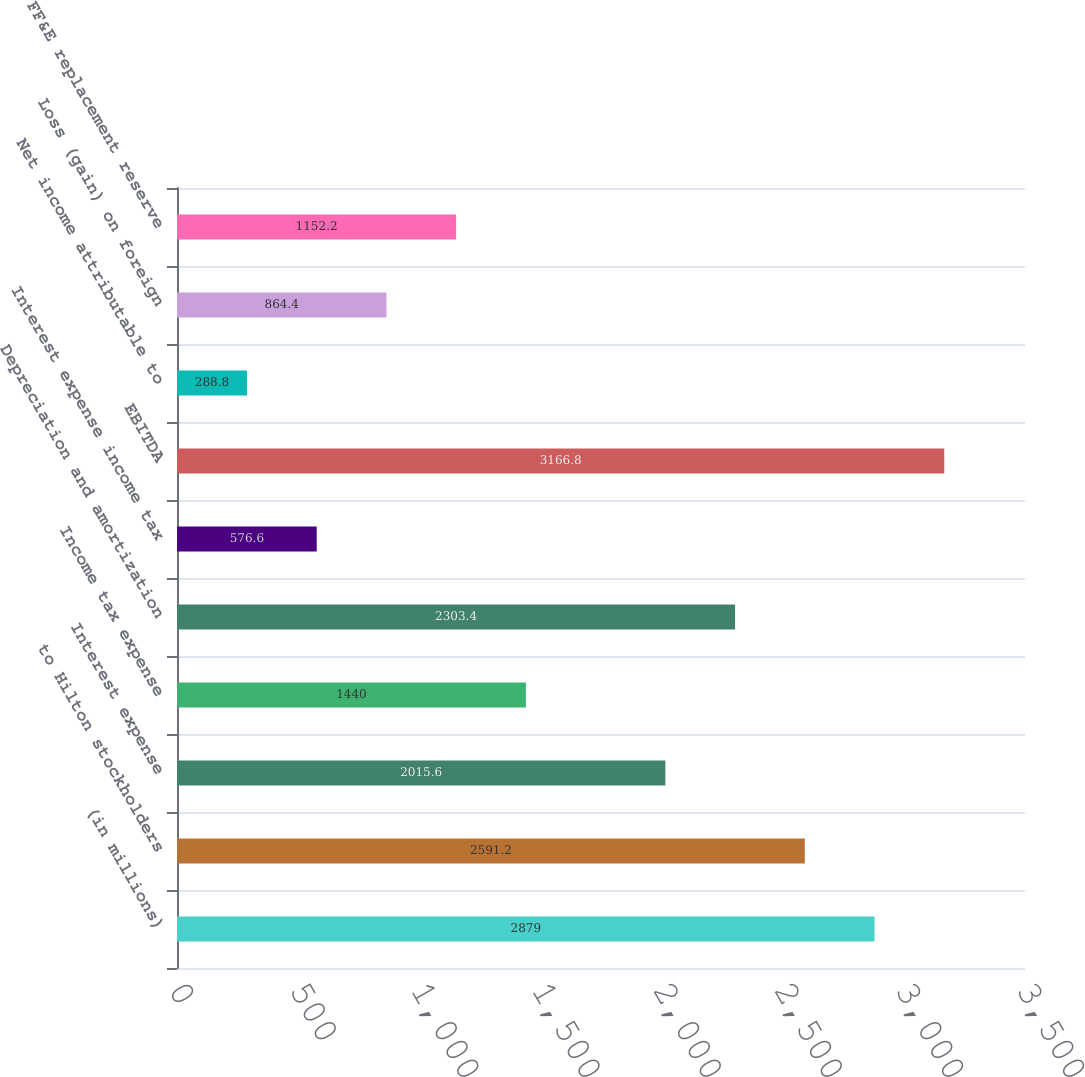Convert chart. <chart><loc_0><loc_0><loc_500><loc_500><bar_chart><fcel>(in millions)<fcel>to Hilton stockholders<fcel>Interest expense<fcel>Income tax expense<fcel>Depreciation and amortization<fcel>Interest expense income tax<fcel>EBITDA<fcel>Net income attributable to<fcel>Loss (gain) on foreign<fcel>FF&E replacement reserve<nl><fcel>2879<fcel>2591.2<fcel>2015.6<fcel>1440<fcel>2303.4<fcel>576.6<fcel>3166.8<fcel>288.8<fcel>864.4<fcel>1152.2<nl></chart> 